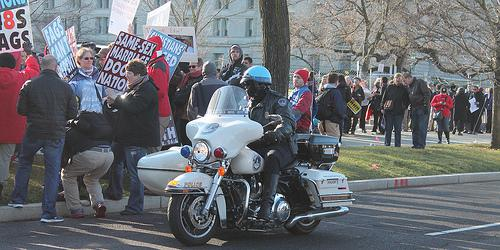Question: what is this photo of?
Choices:
A. People.
B. Protest.
C. Men.
D. Women.
Answer with the letter. Answer: B Question: what are the protesting?
Choices:
A. Gay rights.
B. Equality.
C. Ideas.
D. Same sex marriage.
Answer with the letter. Answer: D Question: who is on the motorcycle?
Choices:
A. Person.
B. Cop.
C. Man.
D. Woman.
Answer with the letter. Answer: B Question: where was this taken?
Choices:
A. Road.
B. Street.
C. Near buildings.
D. Place for cars.
Answer with the letter. Answer: B Question: how many cops are there?
Choices:
A. 1.
B. 2.
C. 4.
D. 10.
Answer with the letter. Answer: A 